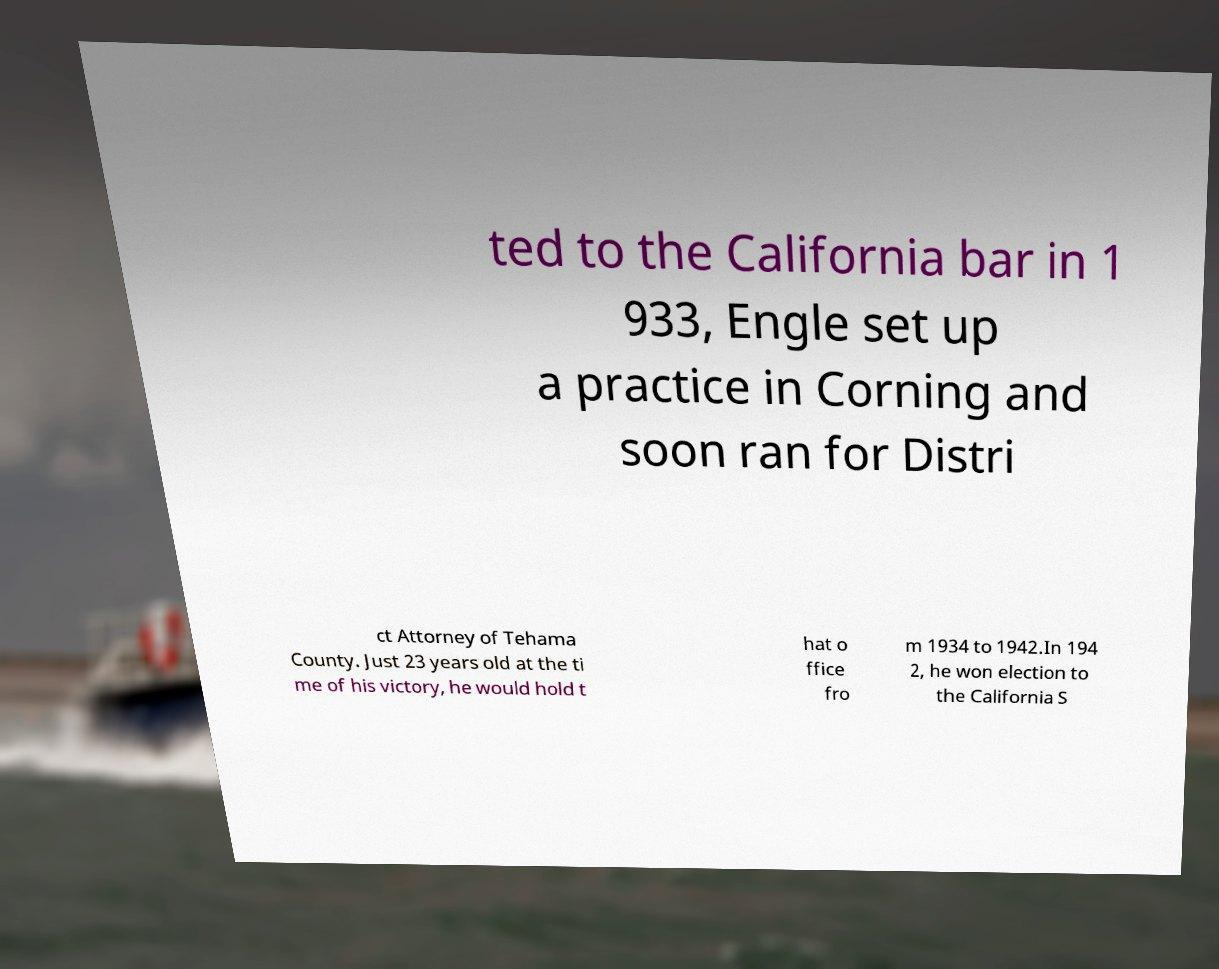There's text embedded in this image that I need extracted. Can you transcribe it verbatim? ted to the California bar in 1 933, Engle set up a practice in Corning and soon ran for Distri ct Attorney of Tehama County. Just 23 years old at the ti me of his victory, he would hold t hat o ffice fro m 1934 to 1942.In 194 2, he won election to the California S 